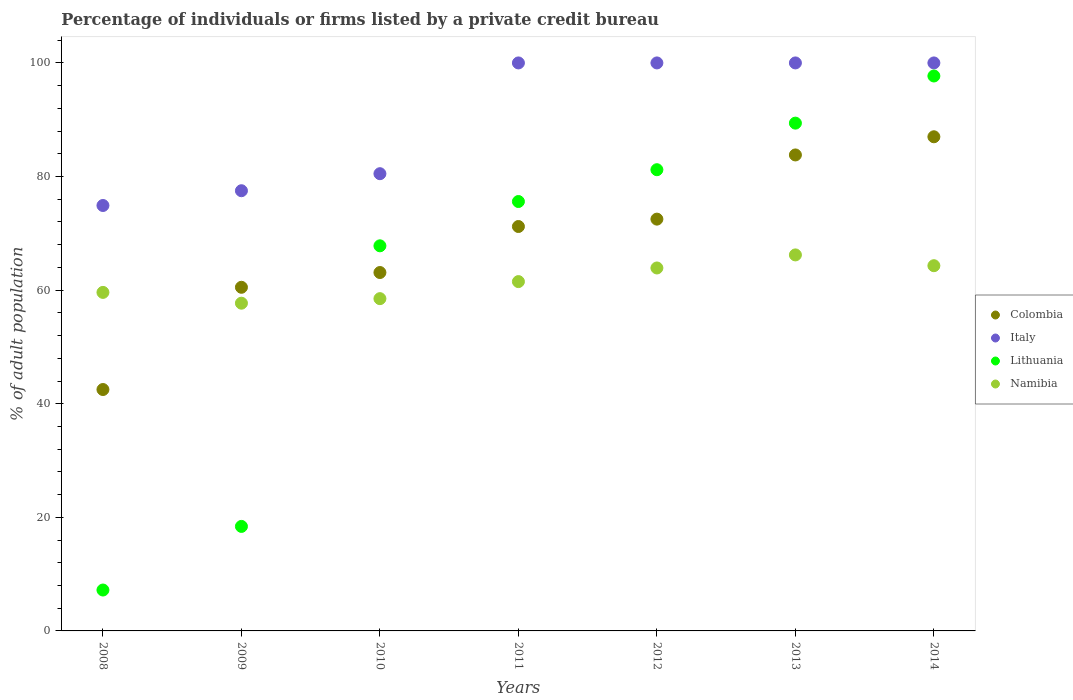What is the percentage of population listed by a private credit bureau in Italy in 2014?
Your response must be concise. 100. Across all years, what is the maximum percentage of population listed by a private credit bureau in Colombia?
Ensure brevity in your answer.  87. Across all years, what is the minimum percentage of population listed by a private credit bureau in Namibia?
Give a very brief answer. 57.7. In which year was the percentage of population listed by a private credit bureau in Colombia maximum?
Provide a short and direct response. 2014. In which year was the percentage of population listed by a private credit bureau in Italy minimum?
Offer a terse response. 2008. What is the total percentage of population listed by a private credit bureau in Lithuania in the graph?
Provide a succinct answer. 437.3. What is the difference between the percentage of population listed by a private credit bureau in Lithuania in 2008 and that in 2011?
Your response must be concise. -68.4. What is the difference between the percentage of population listed by a private credit bureau in Italy in 2011 and the percentage of population listed by a private credit bureau in Namibia in 2012?
Your answer should be very brief. 36.1. What is the average percentage of population listed by a private credit bureau in Colombia per year?
Provide a succinct answer. 68.66. In the year 2012, what is the difference between the percentage of population listed by a private credit bureau in Italy and percentage of population listed by a private credit bureau in Namibia?
Your answer should be compact. 36.1. In how many years, is the percentage of population listed by a private credit bureau in Lithuania greater than 8 %?
Provide a succinct answer. 6. What is the ratio of the percentage of population listed by a private credit bureau in Italy in 2008 to that in 2013?
Offer a terse response. 0.75. Is the percentage of population listed by a private credit bureau in Namibia in 2011 less than that in 2013?
Your answer should be compact. Yes. Is the difference between the percentage of population listed by a private credit bureau in Italy in 2008 and 2013 greater than the difference between the percentage of population listed by a private credit bureau in Namibia in 2008 and 2013?
Your answer should be compact. No. What is the difference between the highest and the second highest percentage of population listed by a private credit bureau in Namibia?
Your answer should be compact. 1.9. What is the difference between the highest and the lowest percentage of population listed by a private credit bureau in Lithuania?
Keep it short and to the point. 90.5. In how many years, is the percentage of population listed by a private credit bureau in Colombia greater than the average percentage of population listed by a private credit bureau in Colombia taken over all years?
Your answer should be very brief. 4. Does the percentage of population listed by a private credit bureau in Lithuania monotonically increase over the years?
Ensure brevity in your answer.  Yes. How many dotlines are there?
Give a very brief answer. 4. How many years are there in the graph?
Keep it short and to the point. 7. Are the values on the major ticks of Y-axis written in scientific E-notation?
Your answer should be compact. No. What is the title of the graph?
Provide a short and direct response. Percentage of individuals or firms listed by a private credit bureau. Does "Solomon Islands" appear as one of the legend labels in the graph?
Provide a succinct answer. No. What is the label or title of the X-axis?
Ensure brevity in your answer.  Years. What is the label or title of the Y-axis?
Ensure brevity in your answer.  % of adult population. What is the % of adult population of Colombia in 2008?
Give a very brief answer. 42.5. What is the % of adult population of Italy in 2008?
Give a very brief answer. 74.9. What is the % of adult population in Lithuania in 2008?
Ensure brevity in your answer.  7.2. What is the % of adult population in Namibia in 2008?
Your response must be concise. 59.6. What is the % of adult population in Colombia in 2009?
Your answer should be compact. 60.5. What is the % of adult population of Italy in 2009?
Give a very brief answer. 77.5. What is the % of adult population of Lithuania in 2009?
Your answer should be compact. 18.4. What is the % of adult population in Namibia in 2009?
Provide a succinct answer. 57.7. What is the % of adult population of Colombia in 2010?
Offer a terse response. 63.1. What is the % of adult population of Italy in 2010?
Your response must be concise. 80.5. What is the % of adult population in Lithuania in 2010?
Your answer should be compact. 67.8. What is the % of adult population in Namibia in 2010?
Give a very brief answer. 58.5. What is the % of adult population of Colombia in 2011?
Offer a very short reply. 71.2. What is the % of adult population in Italy in 2011?
Offer a terse response. 100. What is the % of adult population of Lithuania in 2011?
Give a very brief answer. 75.6. What is the % of adult population in Namibia in 2011?
Make the answer very short. 61.5. What is the % of adult population in Colombia in 2012?
Make the answer very short. 72.5. What is the % of adult population in Lithuania in 2012?
Provide a short and direct response. 81.2. What is the % of adult population in Namibia in 2012?
Your response must be concise. 63.9. What is the % of adult population of Colombia in 2013?
Offer a terse response. 83.8. What is the % of adult population in Lithuania in 2013?
Your response must be concise. 89.4. What is the % of adult population of Namibia in 2013?
Ensure brevity in your answer.  66.2. What is the % of adult population in Colombia in 2014?
Offer a terse response. 87. What is the % of adult population of Italy in 2014?
Your response must be concise. 100. What is the % of adult population of Lithuania in 2014?
Your answer should be compact. 97.7. What is the % of adult population of Namibia in 2014?
Offer a very short reply. 64.3. Across all years, what is the maximum % of adult population in Colombia?
Offer a terse response. 87. Across all years, what is the maximum % of adult population in Italy?
Provide a short and direct response. 100. Across all years, what is the maximum % of adult population of Lithuania?
Provide a short and direct response. 97.7. Across all years, what is the maximum % of adult population in Namibia?
Your answer should be compact. 66.2. Across all years, what is the minimum % of adult population in Colombia?
Provide a succinct answer. 42.5. Across all years, what is the minimum % of adult population of Italy?
Give a very brief answer. 74.9. Across all years, what is the minimum % of adult population of Namibia?
Make the answer very short. 57.7. What is the total % of adult population of Colombia in the graph?
Offer a terse response. 480.6. What is the total % of adult population in Italy in the graph?
Make the answer very short. 632.9. What is the total % of adult population of Lithuania in the graph?
Ensure brevity in your answer.  437.3. What is the total % of adult population in Namibia in the graph?
Your answer should be compact. 431.7. What is the difference between the % of adult population in Lithuania in 2008 and that in 2009?
Provide a succinct answer. -11.2. What is the difference between the % of adult population in Namibia in 2008 and that in 2009?
Provide a succinct answer. 1.9. What is the difference between the % of adult population in Colombia in 2008 and that in 2010?
Ensure brevity in your answer.  -20.6. What is the difference between the % of adult population of Lithuania in 2008 and that in 2010?
Your answer should be very brief. -60.6. What is the difference between the % of adult population of Colombia in 2008 and that in 2011?
Make the answer very short. -28.7. What is the difference between the % of adult population of Italy in 2008 and that in 2011?
Offer a terse response. -25.1. What is the difference between the % of adult population of Lithuania in 2008 and that in 2011?
Your response must be concise. -68.4. What is the difference between the % of adult population of Namibia in 2008 and that in 2011?
Offer a terse response. -1.9. What is the difference between the % of adult population of Italy in 2008 and that in 2012?
Offer a terse response. -25.1. What is the difference between the % of adult population in Lithuania in 2008 and that in 2012?
Your response must be concise. -74. What is the difference between the % of adult population in Namibia in 2008 and that in 2012?
Offer a very short reply. -4.3. What is the difference between the % of adult population of Colombia in 2008 and that in 2013?
Make the answer very short. -41.3. What is the difference between the % of adult population in Italy in 2008 and that in 2013?
Keep it short and to the point. -25.1. What is the difference between the % of adult population of Lithuania in 2008 and that in 2013?
Ensure brevity in your answer.  -82.2. What is the difference between the % of adult population in Colombia in 2008 and that in 2014?
Make the answer very short. -44.5. What is the difference between the % of adult population in Italy in 2008 and that in 2014?
Your response must be concise. -25.1. What is the difference between the % of adult population in Lithuania in 2008 and that in 2014?
Offer a terse response. -90.5. What is the difference between the % of adult population of Namibia in 2008 and that in 2014?
Your response must be concise. -4.7. What is the difference between the % of adult population of Colombia in 2009 and that in 2010?
Your response must be concise. -2.6. What is the difference between the % of adult population of Lithuania in 2009 and that in 2010?
Your answer should be very brief. -49.4. What is the difference between the % of adult population in Italy in 2009 and that in 2011?
Provide a succinct answer. -22.5. What is the difference between the % of adult population in Lithuania in 2009 and that in 2011?
Provide a short and direct response. -57.2. What is the difference between the % of adult population of Italy in 2009 and that in 2012?
Provide a short and direct response. -22.5. What is the difference between the % of adult population of Lithuania in 2009 and that in 2012?
Your response must be concise. -62.8. What is the difference between the % of adult population of Colombia in 2009 and that in 2013?
Make the answer very short. -23.3. What is the difference between the % of adult population of Italy in 2009 and that in 2013?
Give a very brief answer. -22.5. What is the difference between the % of adult population in Lithuania in 2009 and that in 2013?
Give a very brief answer. -71. What is the difference between the % of adult population in Colombia in 2009 and that in 2014?
Provide a succinct answer. -26.5. What is the difference between the % of adult population in Italy in 2009 and that in 2014?
Your response must be concise. -22.5. What is the difference between the % of adult population in Lithuania in 2009 and that in 2014?
Keep it short and to the point. -79.3. What is the difference between the % of adult population in Namibia in 2009 and that in 2014?
Give a very brief answer. -6.6. What is the difference between the % of adult population of Italy in 2010 and that in 2011?
Offer a very short reply. -19.5. What is the difference between the % of adult population in Colombia in 2010 and that in 2012?
Offer a terse response. -9.4. What is the difference between the % of adult population of Italy in 2010 and that in 2012?
Provide a short and direct response. -19.5. What is the difference between the % of adult population in Namibia in 2010 and that in 2012?
Offer a terse response. -5.4. What is the difference between the % of adult population of Colombia in 2010 and that in 2013?
Give a very brief answer. -20.7. What is the difference between the % of adult population in Italy in 2010 and that in 2013?
Your answer should be very brief. -19.5. What is the difference between the % of adult population of Lithuania in 2010 and that in 2013?
Ensure brevity in your answer.  -21.6. What is the difference between the % of adult population of Colombia in 2010 and that in 2014?
Offer a terse response. -23.9. What is the difference between the % of adult population in Italy in 2010 and that in 2014?
Make the answer very short. -19.5. What is the difference between the % of adult population of Lithuania in 2010 and that in 2014?
Ensure brevity in your answer.  -29.9. What is the difference between the % of adult population in Namibia in 2010 and that in 2014?
Provide a short and direct response. -5.8. What is the difference between the % of adult population of Colombia in 2011 and that in 2012?
Your answer should be compact. -1.3. What is the difference between the % of adult population in Italy in 2011 and that in 2012?
Offer a very short reply. 0. What is the difference between the % of adult population of Lithuania in 2011 and that in 2012?
Offer a very short reply. -5.6. What is the difference between the % of adult population in Namibia in 2011 and that in 2012?
Your answer should be very brief. -2.4. What is the difference between the % of adult population in Italy in 2011 and that in 2013?
Offer a very short reply. 0. What is the difference between the % of adult population in Colombia in 2011 and that in 2014?
Ensure brevity in your answer.  -15.8. What is the difference between the % of adult population of Lithuania in 2011 and that in 2014?
Offer a very short reply. -22.1. What is the difference between the % of adult population of Namibia in 2012 and that in 2013?
Ensure brevity in your answer.  -2.3. What is the difference between the % of adult population of Colombia in 2012 and that in 2014?
Keep it short and to the point. -14.5. What is the difference between the % of adult population of Italy in 2012 and that in 2014?
Offer a very short reply. 0. What is the difference between the % of adult population of Lithuania in 2012 and that in 2014?
Keep it short and to the point. -16.5. What is the difference between the % of adult population in Namibia in 2012 and that in 2014?
Your response must be concise. -0.4. What is the difference between the % of adult population of Italy in 2013 and that in 2014?
Your answer should be very brief. 0. What is the difference between the % of adult population of Lithuania in 2013 and that in 2014?
Your answer should be compact. -8.3. What is the difference between the % of adult population of Namibia in 2013 and that in 2014?
Ensure brevity in your answer.  1.9. What is the difference between the % of adult population of Colombia in 2008 and the % of adult population of Italy in 2009?
Your answer should be very brief. -35. What is the difference between the % of adult population of Colombia in 2008 and the % of adult population of Lithuania in 2009?
Your answer should be compact. 24.1. What is the difference between the % of adult population of Colombia in 2008 and the % of adult population of Namibia in 2009?
Ensure brevity in your answer.  -15.2. What is the difference between the % of adult population of Italy in 2008 and the % of adult population of Lithuania in 2009?
Give a very brief answer. 56.5. What is the difference between the % of adult population in Italy in 2008 and the % of adult population in Namibia in 2009?
Make the answer very short. 17.2. What is the difference between the % of adult population in Lithuania in 2008 and the % of adult population in Namibia in 2009?
Keep it short and to the point. -50.5. What is the difference between the % of adult population in Colombia in 2008 and the % of adult population in Italy in 2010?
Keep it short and to the point. -38. What is the difference between the % of adult population in Colombia in 2008 and the % of adult population in Lithuania in 2010?
Offer a terse response. -25.3. What is the difference between the % of adult population in Italy in 2008 and the % of adult population in Namibia in 2010?
Your answer should be compact. 16.4. What is the difference between the % of adult population of Lithuania in 2008 and the % of adult population of Namibia in 2010?
Offer a very short reply. -51.3. What is the difference between the % of adult population of Colombia in 2008 and the % of adult population of Italy in 2011?
Provide a short and direct response. -57.5. What is the difference between the % of adult population in Colombia in 2008 and the % of adult population in Lithuania in 2011?
Ensure brevity in your answer.  -33.1. What is the difference between the % of adult population in Colombia in 2008 and the % of adult population in Namibia in 2011?
Offer a very short reply. -19. What is the difference between the % of adult population in Italy in 2008 and the % of adult population in Namibia in 2011?
Your answer should be very brief. 13.4. What is the difference between the % of adult population of Lithuania in 2008 and the % of adult population of Namibia in 2011?
Ensure brevity in your answer.  -54.3. What is the difference between the % of adult population in Colombia in 2008 and the % of adult population in Italy in 2012?
Offer a very short reply. -57.5. What is the difference between the % of adult population in Colombia in 2008 and the % of adult population in Lithuania in 2012?
Keep it short and to the point. -38.7. What is the difference between the % of adult population in Colombia in 2008 and the % of adult population in Namibia in 2012?
Your response must be concise. -21.4. What is the difference between the % of adult population in Italy in 2008 and the % of adult population in Lithuania in 2012?
Keep it short and to the point. -6.3. What is the difference between the % of adult population of Italy in 2008 and the % of adult population of Namibia in 2012?
Provide a succinct answer. 11. What is the difference between the % of adult population in Lithuania in 2008 and the % of adult population in Namibia in 2012?
Provide a succinct answer. -56.7. What is the difference between the % of adult population in Colombia in 2008 and the % of adult population in Italy in 2013?
Provide a short and direct response. -57.5. What is the difference between the % of adult population in Colombia in 2008 and the % of adult population in Lithuania in 2013?
Keep it short and to the point. -46.9. What is the difference between the % of adult population in Colombia in 2008 and the % of adult population in Namibia in 2013?
Provide a succinct answer. -23.7. What is the difference between the % of adult population of Lithuania in 2008 and the % of adult population of Namibia in 2013?
Your answer should be very brief. -59. What is the difference between the % of adult population of Colombia in 2008 and the % of adult population of Italy in 2014?
Your response must be concise. -57.5. What is the difference between the % of adult population of Colombia in 2008 and the % of adult population of Lithuania in 2014?
Your response must be concise. -55.2. What is the difference between the % of adult population in Colombia in 2008 and the % of adult population in Namibia in 2014?
Offer a terse response. -21.8. What is the difference between the % of adult population in Italy in 2008 and the % of adult population in Lithuania in 2014?
Your answer should be very brief. -22.8. What is the difference between the % of adult population of Lithuania in 2008 and the % of adult population of Namibia in 2014?
Offer a very short reply. -57.1. What is the difference between the % of adult population in Colombia in 2009 and the % of adult population in Italy in 2010?
Provide a succinct answer. -20. What is the difference between the % of adult population of Colombia in 2009 and the % of adult population of Lithuania in 2010?
Offer a terse response. -7.3. What is the difference between the % of adult population of Colombia in 2009 and the % of adult population of Namibia in 2010?
Give a very brief answer. 2. What is the difference between the % of adult population in Lithuania in 2009 and the % of adult population in Namibia in 2010?
Your response must be concise. -40.1. What is the difference between the % of adult population of Colombia in 2009 and the % of adult population of Italy in 2011?
Keep it short and to the point. -39.5. What is the difference between the % of adult population of Colombia in 2009 and the % of adult population of Lithuania in 2011?
Make the answer very short. -15.1. What is the difference between the % of adult population in Italy in 2009 and the % of adult population in Namibia in 2011?
Make the answer very short. 16. What is the difference between the % of adult population of Lithuania in 2009 and the % of adult population of Namibia in 2011?
Give a very brief answer. -43.1. What is the difference between the % of adult population in Colombia in 2009 and the % of adult population in Italy in 2012?
Offer a very short reply. -39.5. What is the difference between the % of adult population of Colombia in 2009 and the % of adult population of Lithuania in 2012?
Ensure brevity in your answer.  -20.7. What is the difference between the % of adult population of Colombia in 2009 and the % of adult population of Namibia in 2012?
Offer a terse response. -3.4. What is the difference between the % of adult population in Italy in 2009 and the % of adult population in Lithuania in 2012?
Give a very brief answer. -3.7. What is the difference between the % of adult population in Italy in 2009 and the % of adult population in Namibia in 2012?
Provide a short and direct response. 13.6. What is the difference between the % of adult population of Lithuania in 2009 and the % of adult population of Namibia in 2012?
Give a very brief answer. -45.5. What is the difference between the % of adult population of Colombia in 2009 and the % of adult population of Italy in 2013?
Keep it short and to the point. -39.5. What is the difference between the % of adult population of Colombia in 2009 and the % of adult population of Lithuania in 2013?
Give a very brief answer. -28.9. What is the difference between the % of adult population of Italy in 2009 and the % of adult population of Lithuania in 2013?
Make the answer very short. -11.9. What is the difference between the % of adult population in Italy in 2009 and the % of adult population in Namibia in 2013?
Your answer should be compact. 11.3. What is the difference between the % of adult population of Lithuania in 2009 and the % of adult population of Namibia in 2013?
Your answer should be compact. -47.8. What is the difference between the % of adult population in Colombia in 2009 and the % of adult population in Italy in 2014?
Ensure brevity in your answer.  -39.5. What is the difference between the % of adult population of Colombia in 2009 and the % of adult population of Lithuania in 2014?
Provide a succinct answer. -37.2. What is the difference between the % of adult population in Italy in 2009 and the % of adult population in Lithuania in 2014?
Offer a very short reply. -20.2. What is the difference between the % of adult population in Italy in 2009 and the % of adult population in Namibia in 2014?
Make the answer very short. 13.2. What is the difference between the % of adult population of Lithuania in 2009 and the % of adult population of Namibia in 2014?
Your answer should be very brief. -45.9. What is the difference between the % of adult population in Colombia in 2010 and the % of adult population in Italy in 2011?
Provide a short and direct response. -36.9. What is the difference between the % of adult population in Colombia in 2010 and the % of adult population in Lithuania in 2011?
Keep it short and to the point. -12.5. What is the difference between the % of adult population of Colombia in 2010 and the % of adult population of Namibia in 2011?
Your answer should be compact. 1.6. What is the difference between the % of adult population of Italy in 2010 and the % of adult population of Namibia in 2011?
Make the answer very short. 19. What is the difference between the % of adult population in Colombia in 2010 and the % of adult population in Italy in 2012?
Your answer should be compact. -36.9. What is the difference between the % of adult population in Colombia in 2010 and the % of adult population in Lithuania in 2012?
Ensure brevity in your answer.  -18.1. What is the difference between the % of adult population of Colombia in 2010 and the % of adult population of Namibia in 2012?
Provide a succinct answer. -0.8. What is the difference between the % of adult population of Italy in 2010 and the % of adult population of Lithuania in 2012?
Provide a short and direct response. -0.7. What is the difference between the % of adult population of Italy in 2010 and the % of adult population of Namibia in 2012?
Your answer should be compact. 16.6. What is the difference between the % of adult population of Lithuania in 2010 and the % of adult population of Namibia in 2012?
Make the answer very short. 3.9. What is the difference between the % of adult population of Colombia in 2010 and the % of adult population of Italy in 2013?
Give a very brief answer. -36.9. What is the difference between the % of adult population in Colombia in 2010 and the % of adult population in Lithuania in 2013?
Your answer should be very brief. -26.3. What is the difference between the % of adult population in Italy in 2010 and the % of adult population in Lithuania in 2013?
Make the answer very short. -8.9. What is the difference between the % of adult population of Italy in 2010 and the % of adult population of Namibia in 2013?
Make the answer very short. 14.3. What is the difference between the % of adult population in Colombia in 2010 and the % of adult population in Italy in 2014?
Offer a terse response. -36.9. What is the difference between the % of adult population in Colombia in 2010 and the % of adult population in Lithuania in 2014?
Ensure brevity in your answer.  -34.6. What is the difference between the % of adult population in Italy in 2010 and the % of adult population in Lithuania in 2014?
Offer a terse response. -17.2. What is the difference between the % of adult population in Italy in 2010 and the % of adult population in Namibia in 2014?
Offer a terse response. 16.2. What is the difference between the % of adult population of Colombia in 2011 and the % of adult population of Italy in 2012?
Keep it short and to the point. -28.8. What is the difference between the % of adult population of Colombia in 2011 and the % of adult population of Lithuania in 2012?
Offer a terse response. -10. What is the difference between the % of adult population of Italy in 2011 and the % of adult population of Namibia in 2012?
Your answer should be compact. 36.1. What is the difference between the % of adult population in Lithuania in 2011 and the % of adult population in Namibia in 2012?
Provide a succinct answer. 11.7. What is the difference between the % of adult population in Colombia in 2011 and the % of adult population in Italy in 2013?
Keep it short and to the point. -28.8. What is the difference between the % of adult population in Colombia in 2011 and the % of adult population in Lithuania in 2013?
Provide a short and direct response. -18.2. What is the difference between the % of adult population in Colombia in 2011 and the % of adult population in Namibia in 2013?
Provide a short and direct response. 5. What is the difference between the % of adult population in Italy in 2011 and the % of adult population in Namibia in 2013?
Provide a succinct answer. 33.8. What is the difference between the % of adult population in Lithuania in 2011 and the % of adult population in Namibia in 2013?
Keep it short and to the point. 9.4. What is the difference between the % of adult population in Colombia in 2011 and the % of adult population in Italy in 2014?
Make the answer very short. -28.8. What is the difference between the % of adult population in Colombia in 2011 and the % of adult population in Lithuania in 2014?
Offer a terse response. -26.5. What is the difference between the % of adult population of Colombia in 2011 and the % of adult population of Namibia in 2014?
Provide a short and direct response. 6.9. What is the difference between the % of adult population of Italy in 2011 and the % of adult population of Namibia in 2014?
Ensure brevity in your answer.  35.7. What is the difference between the % of adult population of Lithuania in 2011 and the % of adult population of Namibia in 2014?
Your answer should be very brief. 11.3. What is the difference between the % of adult population in Colombia in 2012 and the % of adult population in Italy in 2013?
Keep it short and to the point. -27.5. What is the difference between the % of adult population in Colombia in 2012 and the % of adult population in Lithuania in 2013?
Make the answer very short. -16.9. What is the difference between the % of adult population of Italy in 2012 and the % of adult population of Namibia in 2013?
Ensure brevity in your answer.  33.8. What is the difference between the % of adult population of Colombia in 2012 and the % of adult population of Italy in 2014?
Your answer should be compact. -27.5. What is the difference between the % of adult population of Colombia in 2012 and the % of adult population of Lithuania in 2014?
Offer a terse response. -25.2. What is the difference between the % of adult population in Colombia in 2012 and the % of adult population in Namibia in 2014?
Make the answer very short. 8.2. What is the difference between the % of adult population in Italy in 2012 and the % of adult population in Lithuania in 2014?
Ensure brevity in your answer.  2.3. What is the difference between the % of adult population in Italy in 2012 and the % of adult population in Namibia in 2014?
Provide a succinct answer. 35.7. What is the difference between the % of adult population in Lithuania in 2012 and the % of adult population in Namibia in 2014?
Make the answer very short. 16.9. What is the difference between the % of adult population of Colombia in 2013 and the % of adult population of Italy in 2014?
Offer a terse response. -16.2. What is the difference between the % of adult population in Colombia in 2013 and the % of adult population in Namibia in 2014?
Your response must be concise. 19.5. What is the difference between the % of adult population of Italy in 2013 and the % of adult population of Namibia in 2014?
Offer a terse response. 35.7. What is the difference between the % of adult population of Lithuania in 2013 and the % of adult population of Namibia in 2014?
Make the answer very short. 25.1. What is the average % of adult population in Colombia per year?
Make the answer very short. 68.66. What is the average % of adult population in Italy per year?
Provide a succinct answer. 90.41. What is the average % of adult population of Lithuania per year?
Your response must be concise. 62.47. What is the average % of adult population of Namibia per year?
Provide a short and direct response. 61.67. In the year 2008, what is the difference between the % of adult population in Colombia and % of adult population in Italy?
Provide a succinct answer. -32.4. In the year 2008, what is the difference between the % of adult population of Colombia and % of adult population of Lithuania?
Make the answer very short. 35.3. In the year 2008, what is the difference between the % of adult population of Colombia and % of adult population of Namibia?
Give a very brief answer. -17.1. In the year 2008, what is the difference between the % of adult population in Italy and % of adult population in Lithuania?
Keep it short and to the point. 67.7. In the year 2008, what is the difference between the % of adult population in Lithuania and % of adult population in Namibia?
Keep it short and to the point. -52.4. In the year 2009, what is the difference between the % of adult population of Colombia and % of adult population of Italy?
Give a very brief answer. -17. In the year 2009, what is the difference between the % of adult population in Colombia and % of adult population in Lithuania?
Your response must be concise. 42.1. In the year 2009, what is the difference between the % of adult population of Colombia and % of adult population of Namibia?
Ensure brevity in your answer.  2.8. In the year 2009, what is the difference between the % of adult population of Italy and % of adult population of Lithuania?
Your answer should be very brief. 59.1. In the year 2009, what is the difference between the % of adult population of Italy and % of adult population of Namibia?
Give a very brief answer. 19.8. In the year 2009, what is the difference between the % of adult population in Lithuania and % of adult population in Namibia?
Your answer should be compact. -39.3. In the year 2010, what is the difference between the % of adult population in Colombia and % of adult population in Italy?
Your answer should be very brief. -17.4. In the year 2010, what is the difference between the % of adult population of Colombia and % of adult population of Lithuania?
Keep it short and to the point. -4.7. In the year 2010, what is the difference between the % of adult population in Colombia and % of adult population in Namibia?
Your answer should be compact. 4.6. In the year 2011, what is the difference between the % of adult population of Colombia and % of adult population of Italy?
Provide a succinct answer. -28.8. In the year 2011, what is the difference between the % of adult population of Colombia and % of adult population of Lithuania?
Your answer should be very brief. -4.4. In the year 2011, what is the difference between the % of adult population of Colombia and % of adult population of Namibia?
Your answer should be very brief. 9.7. In the year 2011, what is the difference between the % of adult population in Italy and % of adult population in Lithuania?
Your answer should be very brief. 24.4. In the year 2011, what is the difference between the % of adult population of Italy and % of adult population of Namibia?
Your response must be concise. 38.5. In the year 2012, what is the difference between the % of adult population of Colombia and % of adult population of Italy?
Keep it short and to the point. -27.5. In the year 2012, what is the difference between the % of adult population in Italy and % of adult population in Namibia?
Keep it short and to the point. 36.1. In the year 2013, what is the difference between the % of adult population of Colombia and % of adult population of Italy?
Provide a succinct answer. -16.2. In the year 2013, what is the difference between the % of adult population in Colombia and % of adult population in Lithuania?
Your answer should be very brief. -5.6. In the year 2013, what is the difference between the % of adult population of Colombia and % of adult population of Namibia?
Provide a short and direct response. 17.6. In the year 2013, what is the difference between the % of adult population in Italy and % of adult population in Lithuania?
Ensure brevity in your answer.  10.6. In the year 2013, what is the difference between the % of adult population in Italy and % of adult population in Namibia?
Keep it short and to the point. 33.8. In the year 2013, what is the difference between the % of adult population in Lithuania and % of adult population in Namibia?
Provide a short and direct response. 23.2. In the year 2014, what is the difference between the % of adult population of Colombia and % of adult population of Lithuania?
Your answer should be compact. -10.7. In the year 2014, what is the difference between the % of adult population of Colombia and % of adult population of Namibia?
Your response must be concise. 22.7. In the year 2014, what is the difference between the % of adult population in Italy and % of adult population in Namibia?
Your answer should be compact. 35.7. In the year 2014, what is the difference between the % of adult population of Lithuania and % of adult population of Namibia?
Offer a very short reply. 33.4. What is the ratio of the % of adult population in Colombia in 2008 to that in 2009?
Provide a short and direct response. 0.7. What is the ratio of the % of adult population of Italy in 2008 to that in 2009?
Keep it short and to the point. 0.97. What is the ratio of the % of adult population of Lithuania in 2008 to that in 2009?
Give a very brief answer. 0.39. What is the ratio of the % of adult population of Namibia in 2008 to that in 2009?
Your response must be concise. 1.03. What is the ratio of the % of adult population of Colombia in 2008 to that in 2010?
Offer a terse response. 0.67. What is the ratio of the % of adult population of Italy in 2008 to that in 2010?
Ensure brevity in your answer.  0.93. What is the ratio of the % of adult population of Lithuania in 2008 to that in 2010?
Provide a succinct answer. 0.11. What is the ratio of the % of adult population of Namibia in 2008 to that in 2010?
Provide a succinct answer. 1.02. What is the ratio of the % of adult population of Colombia in 2008 to that in 2011?
Give a very brief answer. 0.6. What is the ratio of the % of adult population of Italy in 2008 to that in 2011?
Give a very brief answer. 0.75. What is the ratio of the % of adult population in Lithuania in 2008 to that in 2011?
Your response must be concise. 0.1. What is the ratio of the % of adult population of Namibia in 2008 to that in 2011?
Ensure brevity in your answer.  0.97. What is the ratio of the % of adult population in Colombia in 2008 to that in 2012?
Offer a very short reply. 0.59. What is the ratio of the % of adult population in Italy in 2008 to that in 2012?
Provide a short and direct response. 0.75. What is the ratio of the % of adult population of Lithuania in 2008 to that in 2012?
Keep it short and to the point. 0.09. What is the ratio of the % of adult population in Namibia in 2008 to that in 2012?
Your answer should be very brief. 0.93. What is the ratio of the % of adult population of Colombia in 2008 to that in 2013?
Give a very brief answer. 0.51. What is the ratio of the % of adult population of Italy in 2008 to that in 2013?
Your response must be concise. 0.75. What is the ratio of the % of adult population of Lithuania in 2008 to that in 2013?
Ensure brevity in your answer.  0.08. What is the ratio of the % of adult population in Namibia in 2008 to that in 2013?
Give a very brief answer. 0.9. What is the ratio of the % of adult population of Colombia in 2008 to that in 2014?
Make the answer very short. 0.49. What is the ratio of the % of adult population of Italy in 2008 to that in 2014?
Offer a terse response. 0.75. What is the ratio of the % of adult population of Lithuania in 2008 to that in 2014?
Your answer should be very brief. 0.07. What is the ratio of the % of adult population in Namibia in 2008 to that in 2014?
Offer a very short reply. 0.93. What is the ratio of the % of adult population of Colombia in 2009 to that in 2010?
Offer a terse response. 0.96. What is the ratio of the % of adult population of Italy in 2009 to that in 2010?
Your response must be concise. 0.96. What is the ratio of the % of adult population in Lithuania in 2009 to that in 2010?
Give a very brief answer. 0.27. What is the ratio of the % of adult population in Namibia in 2009 to that in 2010?
Your response must be concise. 0.99. What is the ratio of the % of adult population in Colombia in 2009 to that in 2011?
Provide a succinct answer. 0.85. What is the ratio of the % of adult population in Italy in 2009 to that in 2011?
Your answer should be very brief. 0.78. What is the ratio of the % of adult population in Lithuania in 2009 to that in 2011?
Your answer should be very brief. 0.24. What is the ratio of the % of adult population in Namibia in 2009 to that in 2011?
Make the answer very short. 0.94. What is the ratio of the % of adult population in Colombia in 2009 to that in 2012?
Make the answer very short. 0.83. What is the ratio of the % of adult population of Italy in 2009 to that in 2012?
Provide a short and direct response. 0.78. What is the ratio of the % of adult population of Lithuania in 2009 to that in 2012?
Ensure brevity in your answer.  0.23. What is the ratio of the % of adult population in Namibia in 2009 to that in 2012?
Your answer should be compact. 0.9. What is the ratio of the % of adult population of Colombia in 2009 to that in 2013?
Offer a very short reply. 0.72. What is the ratio of the % of adult population of Italy in 2009 to that in 2013?
Offer a very short reply. 0.78. What is the ratio of the % of adult population of Lithuania in 2009 to that in 2013?
Keep it short and to the point. 0.21. What is the ratio of the % of adult population in Namibia in 2009 to that in 2013?
Give a very brief answer. 0.87. What is the ratio of the % of adult population in Colombia in 2009 to that in 2014?
Your answer should be compact. 0.7. What is the ratio of the % of adult population in Italy in 2009 to that in 2014?
Give a very brief answer. 0.78. What is the ratio of the % of adult population of Lithuania in 2009 to that in 2014?
Your answer should be compact. 0.19. What is the ratio of the % of adult population of Namibia in 2009 to that in 2014?
Provide a short and direct response. 0.9. What is the ratio of the % of adult population in Colombia in 2010 to that in 2011?
Your response must be concise. 0.89. What is the ratio of the % of adult population of Italy in 2010 to that in 2011?
Your answer should be compact. 0.81. What is the ratio of the % of adult population in Lithuania in 2010 to that in 2011?
Provide a short and direct response. 0.9. What is the ratio of the % of adult population in Namibia in 2010 to that in 2011?
Give a very brief answer. 0.95. What is the ratio of the % of adult population in Colombia in 2010 to that in 2012?
Your answer should be very brief. 0.87. What is the ratio of the % of adult population in Italy in 2010 to that in 2012?
Keep it short and to the point. 0.81. What is the ratio of the % of adult population of Lithuania in 2010 to that in 2012?
Ensure brevity in your answer.  0.83. What is the ratio of the % of adult population of Namibia in 2010 to that in 2012?
Provide a short and direct response. 0.92. What is the ratio of the % of adult population of Colombia in 2010 to that in 2013?
Ensure brevity in your answer.  0.75. What is the ratio of the % of adult population in Italy in 2010 to that in 2013?
Ensure brevity in your answer.  0.81. What is the ratio of the % of adult population in Lithuania in 2010 to that in 2013?
Offer a terse response. 0.76. What is the ratio of the % of adult population in Namibia in 2010 to that in 2013?
Make the answer very short. 0.88. What is the ratio of the % of adult population of Colombia in 2010 to that in 2014?
Provide a short and direct response. 0.73. What is the ratio of the % of adult population of Italy in 2010 to that in 2014?
Make the answer very short. 0.81. What is the ratio of the % of adult population in Lithuania in 2010 to that in 2014?
Ensure brevity in your answer.  0.69. What is the ratio of the % of adult population of Namibia in 2010 to that in 2014?
Provide a short and direct response. 0.91. What is the ratio of the % of adult population in Colombia in 2011 to that in 2012?
Provide a succinct answer. 0.98. What is the ratio of the % of adult population in Italy in 2011 to that in 2012?
Your answer should be very brief. 1. What is the ratio of the % of adult population in Namibia in 2011 to that in 2012?
Your response must be concise. 0.96. What is the ratio of the % of adult population in Colombia in 2011 to that in 2013?
Ensure brevity in your answer.  0.85. What is the ratio of the % of adult population in Lithuania in 2011 to that in 2013?
Make the answer very short. 0.85. What is the ratio of the % of adult population of Namibia in 2011 to that in 2013?
Your answer should be compact. 0.93. What is the ratio of the % of adult population in Colombia in 2011 to that in 2014?
Offer a terse response. 0.82. What is the ratio of the % of adult population in Lithuania in 2011 to that in 2014?
Ensure brevity in your answer.  0.77. What is the ratio of the % of adult population in Namibia in 2011 to that in 2014?
Your response must be concise. 0.96. What is the ratio of the % of adult population in Colombia in 2012 to that in 2013?
Provide a succinct answer. 0.87. What is the ratio of the % of adult population in Lithuania in 2012 to that in 2013?
Make the answer very short. 0.91. What is the ratio of the % of adult population in Namibia in 2012 to that in 2013?
Offer a terse response. 0.97. What is the ratio of the % of adult population of Lithuania in 2012 to that in 2014?
Your response must be concise. 0.83. What is the ratio of the % of adult population of Colombia in 2013 to that in 2014?
Your response must be concise. 0.96. What is the ratio of the % of adult population of Lithuania in 2013 to that in 2014?
Your response must be concise. 0.92. What is the ratio of the % of adult population in Namibia in 2013 to that in 2014?
Offer a very short reply. 1.03. What is the difference between the highest and the second highest % of adult population in Lithuania?
Your answer should be very brief. 8.3. What is the difference between the highest and the lowest % of adult population of Colombia?
Give a very brief answer. 44.5. What is the difference between the highest and the lowest % of adult population in Italy?
Your answer should be very brief. 25.1. What is the difference between the highest and the lowest % of adult population of Lithuania?
Ensure brevity in your answer.  90.5. What is the difference between the highest and the lowest % of adult population of Namibia?
Offer a very short reply. 8.5. 